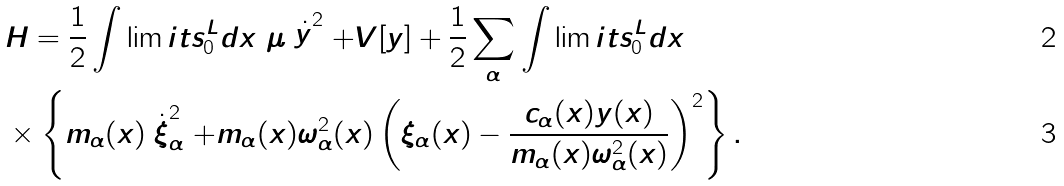Convert formula to latex. <formula><loc_0><loc_0><loc_500><loc_500>& H = \frac { 1 } { 2 } \int \lim i t s _ { 0 } ^ { L } d x \ \mu \stackrel { . } { y } ^ { 2 } + V [ y ] + \frac { 1 } { 2 } \sum _ { \alpha } \int \lim i t s _ { 0 } ^ { L } d x \\ & \times \left \{ m _ { \alpha } ( x ) \stackrel { . } { \xi } _ { \alpha } ^ { 2 } + m _ { \alpha } ( x ) \omega _ { \alpha } ^ { 2 } ( x ) \left ( \xi _ { \alpha } ( x ) - \frac { c _ { \alpha } ( x ) y ( x ) } { m _ { \alpha } ( x ) \omega _ { \alpha } ^ { 2 } ( x ) } \right ) ^ { 2 } \right \} .</formula> 